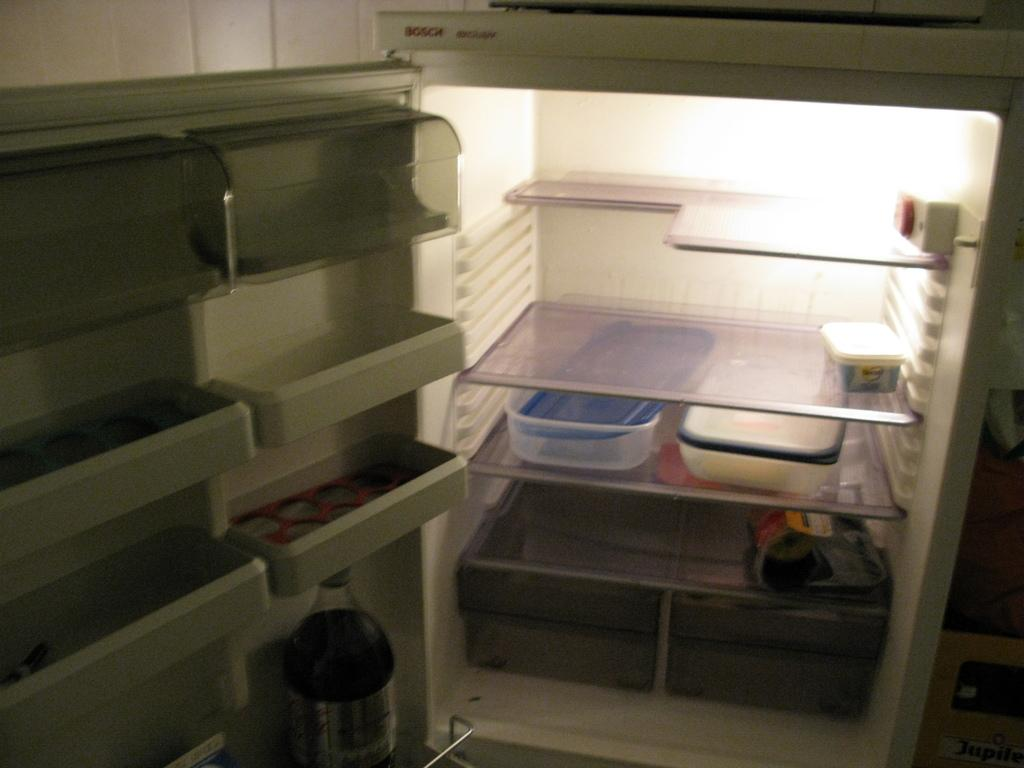What is the main object in the center of the image? There is a refrigerator in the center of the image. What is inside the refrigerator? There are boxes inside the refrigerator. Can you see any other objects besides the refrigerator? Yes, there is a bottle visible in the image. What is the source of light in the image? There is light in the image. What type of prose is written on the calendar in the image? There is no calendar present in the image, so it is not possible to determine if any prose is written on it. 